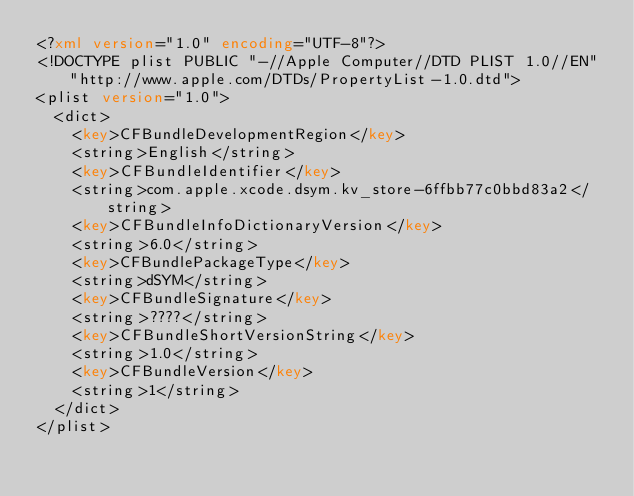Convert code to text. <code><loc_0><loc_0><loc_500><loc_500><_XML_><?xml version="1.0" encoding="UTF-8"?>
<!DOCTYPE plist PUBLIC "-//Apple Computer//DTD PLIST 1.0//EN" "http://www.apple.com/DTDs/PropertyList-1.0.dtd">
<plist version="1.0">
	<dict>
		<key>CFBundleDevelopmentRegion</key>
		<string>English</string>
		<key>CFBundleIdentifier</key>
		<string>com.apple.xcode.dsym.kv_store-6ffbb77c0bbd83a2</string>
		<key>CFBundleInfoDictionaryVersion</key>
		<string>6.0</string>
		<key>CFBundlePackageType</key>
		<string>dSYM</string>
		<key>CFBundleSignature</key>
		<string>????</string>
		<key>CFBundleShortVersionString</key>
		<string>1.0</string>
		<key>CFBundleVersion</key>
		<string>1</string>
	</dict>
</plist>
</code> 